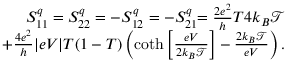Convert formula to latex. <formula><loc_0><loc_0><loc_500><loc_500>\begin{array} { r } { { S _ { 1 1 } ^ { q } = S _ { 2 2 } ^ { q } = - S _ { 1 2 } ^ { q } = - S _ { 2 1 } ^ { q } } { = \frac { 2 e ^ { 2 } } { h } T 4 k _ { B } \mathcal { T } } } \\ { { + \frac { 4 e ^ { 2 } } { h } | e V | T ( 1 - T ) \left ( \coth \left [ \frac { e V } { 2 k _ { B } \mathcal { T } } \right ] - \frac { 2 k _ { B } \mathcal { T } } { e V } \right ) . } } \end{array}</formula> 